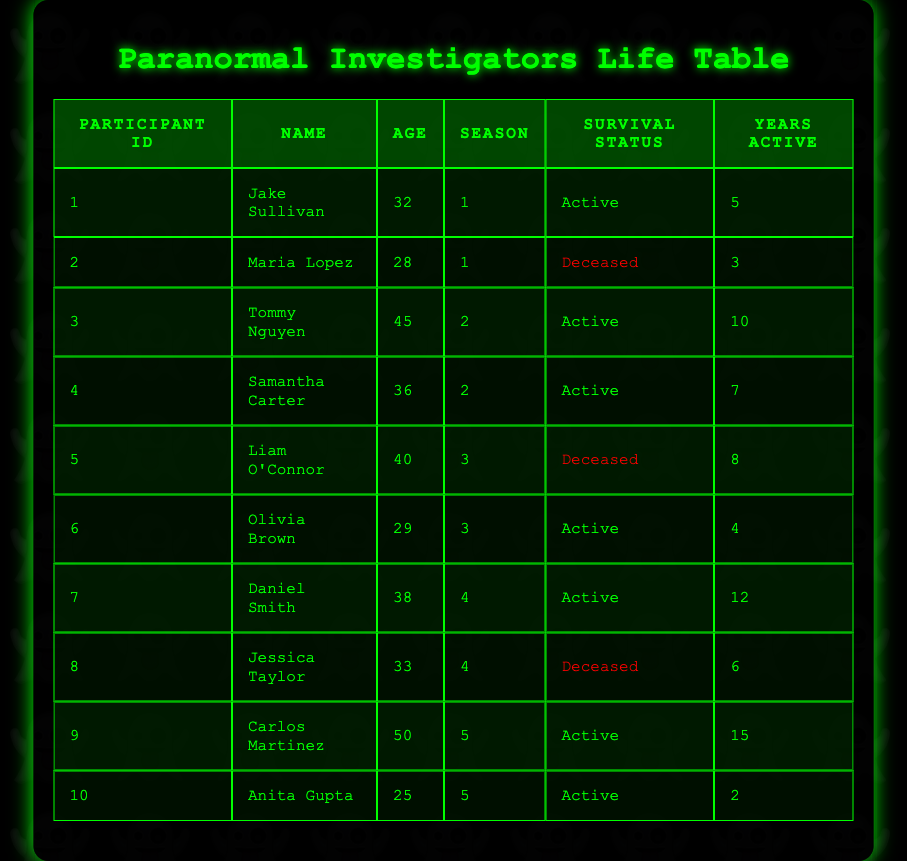What is the age of Liam O'Connor? Liam O'Connor is listed in the table with the information in the Age column corresponding to his Participant ID, which states he is 40 years old.
Answer: 40 How many participants are currently active? To find the number of active participants, we can look at the Survival Status column and count how many entries are marked as "Active." Upon review, there are 6 participants who are active.
Answer: 6 What is the average age of participants who are deceased? First, we identify the ages of deceased participants, which are Maria Lopez (28) and Liam O'Connor (40) and Jessica Taylor (33). The sum of their ages is 28 + 40 + 33 = 101. There are 3 deceased participants, so the average age is 101 / 3 = 33.67.
Answer: 33.67 Is Carlos Martinez older than Tom Nguyen? To determine if this is true, we need to compare their ages listed in the Age column: Carlos Martinez is 50 years old, while Tommy Nguyen is 45 years old. Since 50 is greater than 45, the statement is true.
Answer: Yes How many years of experience in paranormal investigation does the oldest active participant have? First, we find the ages of active participants, which are 32 (Jake Sullivan), 45 (Tommy Nguyen), 36 (Samantha Carter), 29 (Olivia Brown), 38 (Daniel Smith), and 50 (Carlos Martinez). The oldest active participant is Carlos Martinez, who is 50 years old. He has 15 years of experience in paranormal investigation, as indicated in the Years Active column.
Answer: 15 